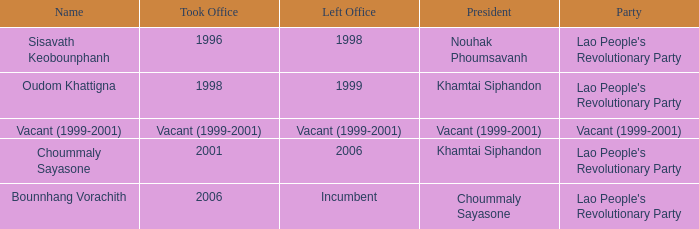What is departed office, when party is vacant (1999-2001)? Vacant (1999-2001). 